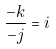<formula> <loc_0><loc_0><loc_500><loc_500>\frac { - k } { - j } = i</formula> 